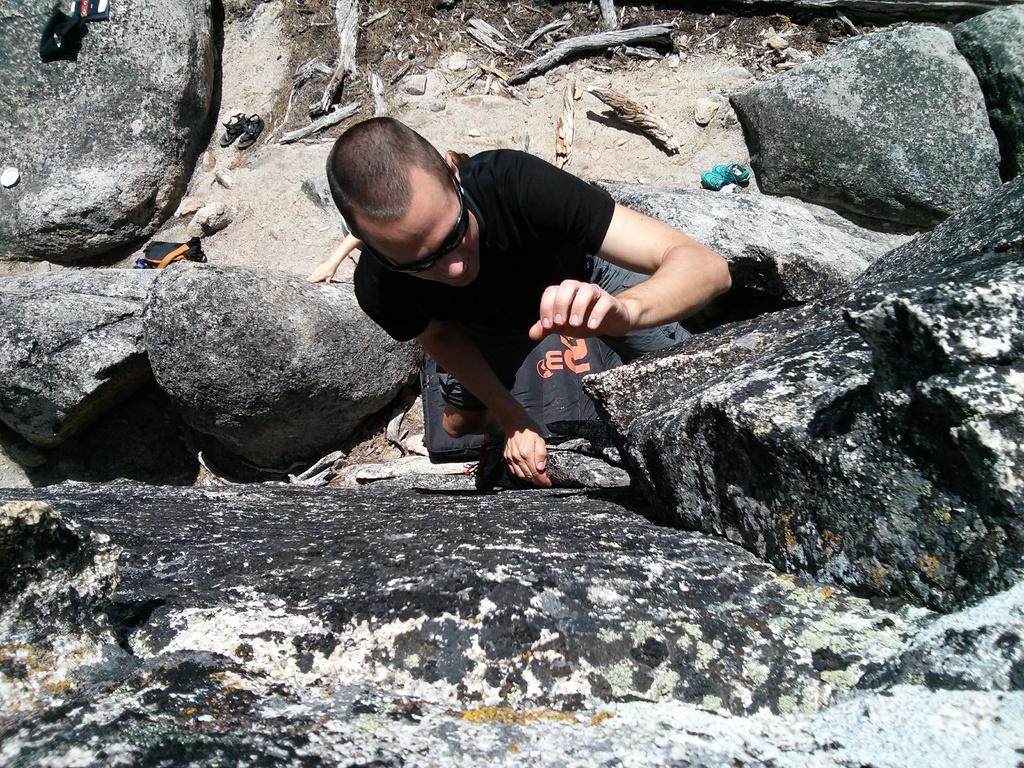What is the main subject of the image? There is a person standing in the center of the image. Can you describe the person's appearance? The person is wearing spectacles. What can be seen in the background of the image? There are slippers, a bag, and rocks in the background of the image. How many eggs are being divided among the waste in the image? There are no eggs or waste present in the image. 